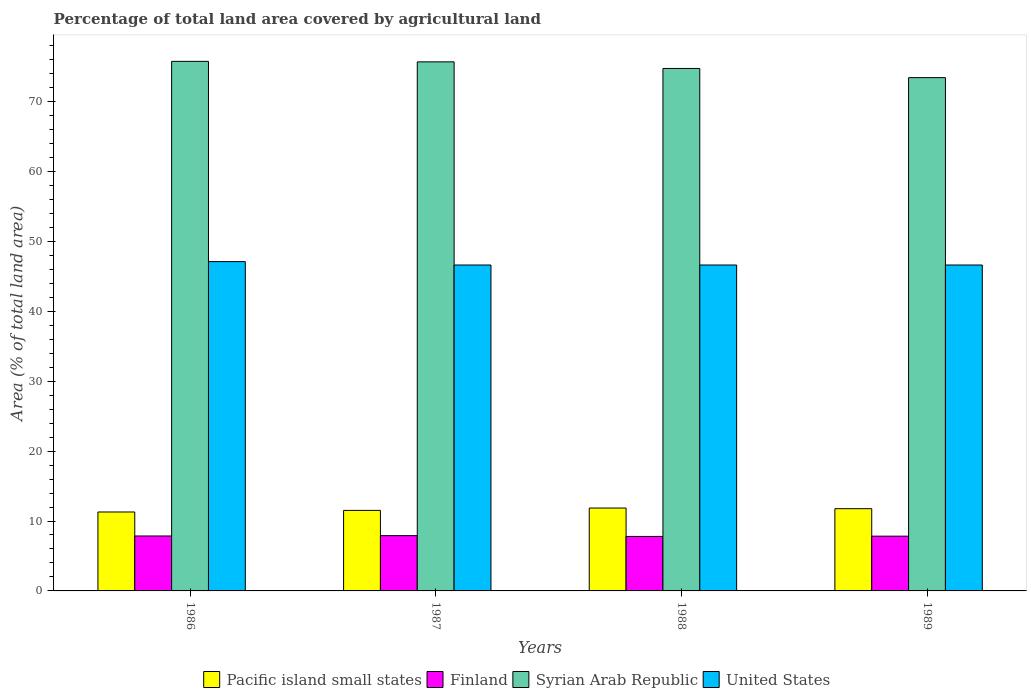How many bars are there on the 1st tick from the left?
Your answer should be compact. 4. What is the label of the 4th group of bars from the left?
Your answer should be compact. 1989. What is the percentage of agricultural land in Pacific island small states in 1989?
Make the answer very short. 11.76. Across all years, what is the maximum percentage of agricultural land in Finland?
Offer a terse response. 7.91. Across all years, what is the minimum percentage of agricultural land in Pacific island small states?
Offer a very short reply. 11.29. In which year was the percentage of agricultural land in Syrian Arab Republic maximum?
Make the answer very short. 1986. What is the total percentage of agricultural land in United States in the graph?
Keep it short and to the point. 186.95. What is the difference between the percentage of agricultural land in United States in 1988 and that in 1989?
Ensure brevity in your answer.  0. What is the difference between the percentage of agricultural land in United States in 1986 and the percentage of agricultural land in Syrian Arab Republic in 1989?
Ensure brevity in your answer.  -26.31. What is the average percentage of agricultural land in Finland per year?
Provide a succinct answer. 7.85. In the year 1986, what is the difference between the percentage of agricultural land in United States and percentage of agricultural land in Pacific island small states?
Your response must be concise. 35.81. What is the ratio of the percentage of agricultural land in Syrian Arab Republic in 1987 to that in 1989?
Keep it short and to the point. 1.03. Is the difference between the percentage of agricultural land in United States in 1987 and 1988 greater than the difference between the percentage of agricultural land in Pacific island small states in 1987 and 1988?
Your answer should be very brief. Yes. What is the difference between the highest and the second highest percentage of agricultural land in Finland?
Your response must be concise. 0.05. What is the difference between the highest and the lowest percentage of agricultural land in Pacific island small states?
Make the answer very short. 0.57. In how many years, is the percentage of agricultural land in United States greater than the average percentage of agricultural land in United States taken over all years?
Ensure brevity in your answer.  1. Is it the case that in every year, the sum of the percentage of agricultural land in Syrian Arab Republic and percentage of agricultural land in United States is greater than the sum of percentage of agricultural land in Pacific island small states and percentage of agricultural land in Finland?
Make the answer very short. Yes. What does the 2nd bar from the left in 1987 represents?
Provide a short and direct response. Finland. Is it the case that in every year, the sum of the percentage of agricultural land in Pacific island small states and percentage of agricultural land in United States is greater than the percentage of agricultural land in Syrian Arab Republic?
Your answer should be very brief. No. How many bars are there?
Ensure brevity in your answer.  16. How many years are there in the graph?
Provide a short and direct response. 4. What is the difference between two consecutive major ticks on the Y-axis?
Offer a terse response. 10. Does the graph contain any zero values?
Your answer should be very brief. No. Does the graph contain grids?
Your response must be concise. No. Where does the legend appear in the graph?
Ensure brevity in your answer.  Bottom center. How are the legend labels stacked?
Ensure brevity in your answer.  Horizontal. What is the title of the graph?
Offer a very short reply. Percentage of total land area covered by agricultural land. Does "Middle East & North Africa (all income levels)" appear as one of the legend labels in the graph?
Your response must be concise. No. What is the label or title of the Y-axis?
Keep it short and to the point. Area (% of total land area). What is the Area (% of total land area) of Pacific island small states in 1986?
Provide a short and direct response. 11.29. What is the Area (% of total land area) in Finland in 1986?
Your response must be concise. 7.86. What is the Area (% of total land area) of Syrian Arab Republic in 1986?
Your answer should be very brief. 75.74. What is the Area (% of total land area) of United States in 1986?
Make the answer very short. 47.1. What is the Area (% of total land area) of Pacific island small states in 1987?
Provide a short and direct response. 11.52. What is the Area (% of total land area) in Finland in 1987?
Provide a succinct answer. 7.91. What is the Area (% of total land area) of Syrian Arab Republic in 1987?
Provide a succinct answer. 75.67. What is the Area (% of total land area) of United States in 1987?
Keep it short and to the point. 46.62. What is the Area (% of total land area) of Pacific island small states in 1988?
Offer a very short reply. 11.86. What is the Area (% of total land area) in Finland in 1988?
Your answer should be compact. 7.79. What is the Area (% of total land area) in Syrian Arab Republic in 1988?
Your answer should be compact. 74.73. What is the Area (% of total land area) of United States in 1988?
Ensure brevity in your answer.  46.62. What is the Area (% of total land area) of Pacific island small states in 1989?
Offer a terse response. 11.76. What is the Area (% of total land area) in Finland in 1989?
Keep it short and to the point. 7.83. What is the Area (% of total land area) in Syrian Arab Republic in 1989?
Offer a very short reply. 73.41. What is the Area (% of total land area) of United States in 1989?
Give a very brief answer. 46.62. Across all years, what is the maximum Area (% of total land area) of Pacific island small states?
Make the answer very short. 11.86. Across all years, what is the maximum Area (% of total land area) of Finland?
Make the answer very short. 7.91. Across all years, what is the maximum Area (% of total land area) of Syrian Arab Republic?
Provide a succinct answer. 75.74. Across all years, what is the maximum Area (% of total land area) in United States?
Make the answer very short. 47.1. Across all years, what is the minimum Area (% of total land area) in Pacific island small states?
Offer a very short reply. 11.29. Across all years, what is the minimum Area (% of total land area) of Finland?
Provide a short and direct response. 7.79. Across all years, what is the minimum Area (% of total land area) of Syrian Arab Republic?
Your answer should be very brief. 73.41. Across all years, what is the minimum Area (% of total land area) in United States?
Provide a succinct answer. 46.62. What is the total Area (% of total land area) of Pacific island small states in the graph?
Your response must be concise. 46.42. What is the total Area (% of total land area) of Finland in the graph?
Give a very brief answer. 31.39. What is the total Area (% of total land area) in Syrian Arab Republic in the graph?
Provide a short and direct response. 299.55. What is the total Area (% of total land area) of United States in the graph?
Your answer should be compact. 186.95. What is the difference between the Area (% of total land area) in Pacific island small states in 1986 and that in 1987?
Ensure brevity in your answer.  -0.23. What is the difference between the Area (% of total land area) of Finland in 1986 and that in 1987?
Offer a very short reply. -0.05. What is the difference between the Area (% of total land area) of Syrian Arab Republic in 1986 and that in 1987?
Your answer should be compact. 0.07. What is the difference between the Area (% of total land area) in United States in 1986 and that in 1987?
Your answer should be compact. 0.49. What is the difference between the Area (% of total land area) of Pacific island small states in 1986 and that in 1988?
Ensure brevity in your answer.  -0.57. What is the difference between the Area (% of total land area) in Finland in 1986 and that in 1988?
Offer a terse response. 0.07. What is the difference between the Area (% of total land area) of Syrian Arab Republic in 1986 and that in 1988?
Keep it short and to the point. 1.02. What is the difference between the Area (% of total land area) in United States in 1986 and that in 1988?
Your response must be concise. 0.49. What is the difference between the Area (% of total land area) of Pacific island small states in 1986 and that in 1989?
Provide a succinct answer. -0.47. What is the difference between the Area (% of total land area) in Finland in 1986 and that in 1989?
Your response must be concise. 0.03. What is the difference between the Area (% of total land area) in Syrian Arab Republic in 1986 and that in 1989?
Offer a terse response. 2.33. What is the difference between the Area (% of total land area) in United States in 1986 and that in 1989?
Your answer should be compact. 0.49. What is the difference between the Area (% of total land area) in Pacific island small states in 1987 and that in 1988?
Ensure brevity in your answer.  -0.34. What is the difference between the Area (% of total land area) in Finland in 1987 and that in 1988?
Ensure brevity in your answer.  0.11. What is the difference between the Area (% of total land area) in Syrian Arab Republic in 1987 and that in 1988?
Keep it short and to the point. 0.95. What is the difference between the Area (% of total land area) in Pacific island small states in 1987 and that in 1989?
Provide a succinct answer. -0.25. What is the difference between the Area (% of total land area) in Finland in 1987 and that in 1989?
Your answer should be compact. 0.07. What is the difference between the Area (% of total land area) of Syrian Arab Republic in 1987 and that in 1989?
Provide a short and direct response. 2.26. What is the difference between the Area (% of total land area) of United States in 1987 and that in 1989?
Give a very brief answer. 0. What is the difference between the Area (% of total land area) of Pacific island small states in 1988 and that in 1989?
Provide a succinct answer. 0.09. What is the difference between the Area (% of total land area) of Finland in 1988 and that in 1989?
Ensure brevity in your answer.  -0.04. What is the difference between the Area (% of total land area) of Syrian Arab Republic in 1988 and that in 1989?
Your response must be concise. 1.31. What is the difference between the Area (% of total land area) in United States in 1988 and that in 1989?
Give a very brief answer. 0. What is the difference between the Area (% of total land area) in Pacific island small states in 1986 and the Area (% of total land area) in Finland in 1987?
Your answer should be compact. 3.38. What is the difference between the Area (% of total land area) of Pacific island small states in 1986 and the Area (% of total land area) of Syrian Arab Republic in 1987?
Provide a short and direct response. -64.38. What is the difference between the Area (% of total land area) of Pacific island small states in 1986 and the Area (% of total land area) of United States in 1987?
Your answer should be very brief. -35.33. What is the difference between the Area (% of total land area) in Finland in 1986 and the Area (% of total land area) in Syrian Arab Republic in 1987?
Provide a short and direct response. -67.81. What is the difference between the Area (% of total land area) in Finland in 1986 and the Area (% of total land area) in United States in 1987?
Offer a terse response. -38.76. What is the difference between the Area (% of total land area) in Syrian Arab Republic in 1986 and the Area (% of total land area) in United States in 1987?
Keep it short and to the point. 29.13. What is the difference between the Area (% of total land area) in Pacific island small states in 1986 and the Area (% of total land area) in Finland in 1988?
Your answer should be compact. 3.5. What is the difference between the Area (% of total land area) of Pacific island small states in 1986 and the Area (% of total land area) of Syrian Arab Republic in 1988?
Ensure brevity in your answer.  -63.44. What is the difference between the Area (% of total land area) in Pacific island small states in 1986 and the Area (% of total land area) in United States in 1988?
Ensure brevity in your answer.  -35.33. What is the difference between the Area (% of total land area) of Finland in 1986 and the Area (% of total land area) of Syrian Arab Republic in 1988?
Your answer should be very brief. -66.87. What is the difference between the Area (% of total land area) in Finland in 1986 and the Area (% of total land area) in United States in 1988?
Your answer should be compact. -38.76. What is the difference between the Area (% of total land area) of Syrian Arab Republic in 1986 and the Area (% of total land area) of United States in 1988?
Keep it short and to the point. 29.13. What is the difference between the Area (% of total land area) in Pacific island small states in 1986 and the Area (% of total land area) in Finland in 1989?
Offer a very short reply. 3.46. What is the difference between the Area (% of total land area) in Pacific island small states in 1986 and the Area (% of total land area) in Syrian Arab Republic in 1989?
Offer a very short reply. -62.12. What is the difference between the Area (% of total land area) of Pacific island small states in 1986 and the Area (% of total land area) of United States in 1989?
Keep it short and to the point. -35.33. What is the difference between the Area (% of total land area) of Finland in 1986 and the Area (% of total land area) of Syrian Arab Republic in 1989?
Provide a succinct answer. -65.56. What is the difference between the Area (% of total land area) of Finland in 1986 and the Area (% of total land area) of United States in 1989?
Give a very brief answer. -38.76. What is the difference between the Area (% of total land area) in Syrian Arab Republic in 1986 and the Area (% of total land area) in United States in 1989?
Give a very brief answer. 29.13. What is the difference between the Area (% of total land area) in Pacific island small states in 1987 and the Area (% of total land area) in Finland in 1988?
Offer a terse response. 3.73. What is the difference between the Area (% of total land area) in Pacific island small states in 1987 and the Area (% of total land area) in Syrian Arab Republic in 1988?
Your response must be concise. -63.21. What is the difference between the Area (% of total land area) of Pacific island small states in 1987 and the Area (% of total land area) of United States in 1988?
Your answer should be very brief. -35.1. What is the difference between the Area (% of total land area) of Finland in 1987 and the Area (% of total land area) of Syrian Arab Republic in 1988?
Offer a very short reply. -66.82. What is the difference between the Area (% of total land area) in Finland in 1987 and the Area (% of total land area) in United States in 1988?
Make the answer very short. -38.71. What is the difference between the Area (% of total land area) of Syrian Arab Republic in 1987 and the Area (% of total land area) of United States in 1988?
Offer a very short reply. 29.06. What is the difference between the Area (% of total land area) of Pacific island small states in 1987 and the Area (% of total land area) of Finland in 1989?
Keep it short and to the point. 3.68. What is the difference between the Area (% of total land area) of Pacific island small states in 1987 and the Area (% of total land area) of Syrian Arab Republic in 1989?
Provide a succinct answer. -61.9. What is the difference between the Area (% of total land area) of Pacific island small states in 1987 and the Area (% of total land area) of United States in 1989?
Provide a succinct answer. -35.1. What is the difference between the Area (% of total land area) in Finland in 1987 and the Area (% of total land area) in Syrian Arab Republic in 1989?
Your answer should be very brief. -65.51. What is the difference between the Area (% of total land area) of Finland in 1987 and the Area (% of total land area) of United States in 1989?
Your answer should be very brief. -38.71. What is the difference between the Area (% of total land area) of Syrian Arab Republic in 1987 and the Area (% of total land area) of United States in 1989?
Your response must be concise. 29.06. What is the difference between the Area (% of total land area) in Pacific island small states in 1988 and the Area (% of total land area) in Finland in 1989?
Make the answer very short. 4.02. What is the difference between the Area (% of total land area) in Pacific island small states in 1988 and the Area (% of total land area) in Syrian Arab Republic in 1989?
Make the answer very short. -61.56. What is the difference between the Area (% of total land area) in Pacific island small states in 1988 and the Area (% of total land area) in United States in 1989?
Your response must be concise. -34.76. What is the difference between the Area (% of total land area) in Finland in 1988 and the Area (% of total land area) in Syrian Arab Republic in 1989?
Offer a very short reply. -65.62. What is the difference between the Area (% of total land area) of Finland in 1988 and the Area (% of total land area) of United States in 1989?
Give a very brief answer. -38.82. What is the difference between the Area (% of total land area) of Syrian Arab Republic in 1988 and the Area (% of total land area) of United States in 1989?
Give a very brief answer. 28.11. What is the average Area (% of total land area) in Pacific island small states per year?
Provide a short and direct response. 11.61. What is the average Area (% of total land area) in Finland per year?
Your response must be concise. 7.85. What is the average Area (% of total land area) in Syrian Arab Republic per year?
Keep it short and to the point. 74.89. What is the average Area (% of total land area) of United States per year?
Offer a very short reply. 46.74. In the year 1986, what is the difference between the Area (% of total land area) of Pacific island small states and Area (% of total land area) of Finland?
Offer a very short reply. 3.43. In the year 1986, what is the difference between the Area (% of total land area) of Pacific island small states and Area (% of total land area) of Syrian Arab Republic?
Offer a very short reply. -64.45. In the year 1986, what is the difference between the Area (% of total land area) of Pacific island small states and Area (% of total land area) of United States?
Keep it short and to the point. -35.81. In the year 1986, what is the difference between the Area (% of total land area) in Finland and Area (% of total land area) in Syrian Arab Republic?
Your response must be concise. -67.89. In the year 1986, what is the difference between the Area (% of total land area) in Finland and Area (% of total land area) in United States?
Ensure brevity in your answer.  -39.24. In the year 1986, what is the difference between the Area (% of total land area) in Syrian Arab Republic and Area (% of total land area) in United States?
Give a very brief answer. 28.64. In the year 1987, what is the difference between the Area (% of total land area) in Pacific island small states and Area (% of total land area) in Finland?
Your answer should be compact. 3.61. In the year 1987, what is the difference between the Area (% of total land area) of Pacific island small states and Area (% of total land area) of Syrian Arab Republic?
Offer a terse response. -64.16. In the year 1987, what is the difference between the Area (% of total land area) of Pacific island small states and Area (% of total land area) of United States?
Your response must be concise. -35.1. In the year 1987, what is the difference between the Area (% of total land area) of Finland and Area (% of total land area) of Syrian Arab Republic?
Your answer should be very brief. -67.77. In the year 1987, what is the difference between the Area (% of total land area) of Finland and Area (% of total land area) of United States?
Provide a short and direct response. -38.71. In the year 1987, what is the difference between the Area (% of total land area) in Syrian Arab Republic and Area (% of total land area) in United States?
Give a very brief answer. 29.06. In the year 1988, what is the difference between the Area (% of total land area) of Pacific island small states and Area (% of total land area) of Finland?
Your answer should be very brief. 4.06. In the year 1988, what is the difference between the Area (% of total land area) of Pacific island small states and Area (% of total land area) of Syrian Arab Republic?
Your answer should be compact. -62.87. In the year 1988, what is the difference between the Area (% of total land area) in Pacific island small states and Area (% of total land area) in United States?
Provide a succinct answer. -34.76. In the year 1988, what is the difference between the Area (% of total land area) of Finland and Area (% of total land area) of Syrian Arab Republic?
Your answer should be compact. -66.93. In the year 1988, what is the difference between the Area (% of total land area) in Finland and Area (% of total land area) in United States?
Your answer should be compact. -38.82. In the year 1988, what is the difference between the Area (% of total land area) in Syrian Arab Republic and Area (% of total land area) in United States?
Your answer should be very brief. 28.11. In the year 1989, what is the difference between the Area (% of total land area) in Pacific island small states and Area (% of total land area) in Finland?
Your response must be concise. 3.93. In the year 1989, what is the difference between the Area (% of total land area) of Pacific island small states and Area (% of total land area) of Syrian Arab Republic?
Ensure brevity in your answer.  -61.65. In the year 1989, what is the difference between the Area (% of total land area) in Pacific island small states and Area (% of total land area) in United States?
Give a very brief answer. -34.85. In the year 1989, what is the difference between the Area (% of total land area) of Finland and Area (% of total land area) of Syrian Arab Republic?
Your answer should be compact. -65.58. In the year 1989, what is the difference between the Area (% of total land area) of Finland and Area (% of total land area) of United States?
Offer a terse response. -38.78. In the year 1989, what is the difference between the Area (% of total land area) in Syrian Arab Republic and Area (% of total land area) in United States?
Your answer should be very brief. 26.8. What is the ratio of the Area (% of total land area) in Pacific island small states in 1986 to that in 1987?
Keep it short and to the point. 0.98. What is the ratio of the Area (% of total land area) in Finland in 1986 to that in 1987?
Ensure brevity in your answer.  0.99. What is the ratio of the Area (% of total land area) in Syrian Arab Republic in 1986 to that in 1987?
Your answer should be very brief. 1. What is the ratio of the Area (% of total land area) of United States in 1986 to that in 1987?
Give a very brief answer. 1.01. What is the ratio of the Area (% of total land area) in Pacific island small states in 1986 to that in 1988?
Your answer should be compact. 0.95. What is the ratio of the Area (% of total land area) in Finland in 1986 to that in 1988?
Ensure brevity in your answer.  1.01. What is the ratio of the Area (% of total land area) in Syrian Arab Republic in 1986 to that in 1988?
Your answer should be very brief. 1.01. What is the ratio of the Area (% of total land area) in United States in 1986 to that in 1988?
Your answer should be very brief. 1.01. What is the ratio of the Area (% of total land area) of Pacific island small states in 1986 to that in 1989?
Ensure brevity in your answer.  0.96. What is the ratio of the Area (% of total land area) of Syrian Arab Republic in 1986 to that in 1989?
Ensure brevity in your answer.  1.03. What is the ratio of the Area (% of total land area) of United States in 1986 to that in 1989?
Keep it short and to the point. 1.01. What is the ratio of the Area (% of total land area) of Pacific island small states in 1987 to that in 1988?
Your response must be concise. 0.97. What is the ratio of the Area (% of total land area) in Finland in 1987 to that in 1988?
Ensure brevity in your answer.  1.01. What is the ratio of the Area (% of total land area) in Syrian Arab Republic in 1987 to that in 1988?
Keep it short and to the point. 1.01. What is the ratio of the Area (% of total land area) of United States in 1987 to that in 1988?
Make the answer very short. 1. What is the ratio of the Area (% of total land area) of Finland in 1987 to that in 1989?
Give a very brief answer. 1.01. What is the ratio of the Area (% of total land area) in Syrian Arab Republic in 1987 to that in 1989?
Make the answer very short. 1.03. What is the ratio of the Area (% of total land area) of United States in 1987 to that in 1989?
Your answer should be very brief. 1. What is the ratio of the Area (% of total land area) in Finland in 1988 to that in 1989?
Offer a terse response. 0.99. What is the ratio of the Area (% of total land area) in Syrian Arab Republic in 1988 to that in 1989?
Make the answer very short. 1.02. What is the difference between the highest and the second highest Area (% of total land area) in Pacific island small states?
Your answer should be very brief. 0.09. What is the difference between the highest and the second highest Area (% of total land area) in Finland?
Make the answer very short. 0.05. What is the difference between the highest and the second highest Area (% of total land area) in Syrian Arab Republic?
Offer a terse response. 0.07. What is the difference between the highest and the second highest Area (% of total land area) in United States?
Your response must be concise. 0.49. What is the difference between the highest and the lowest Area (% of total land area) in Pacific island small states?
Your answer should be very brief. 0.57. What is the difference between the highest and the lowest Area (% of total land area) of Finland?
Offer a very short reply. 0.11. What is the difference between the highest and the lowest Area (% of total land area) in Syrian Arab Republic?
Offer a terse response. 2.33. What is the difference between the highest and the lowest Area (% of total land area) of United States?
Your answer should be very brief. 0.49. 